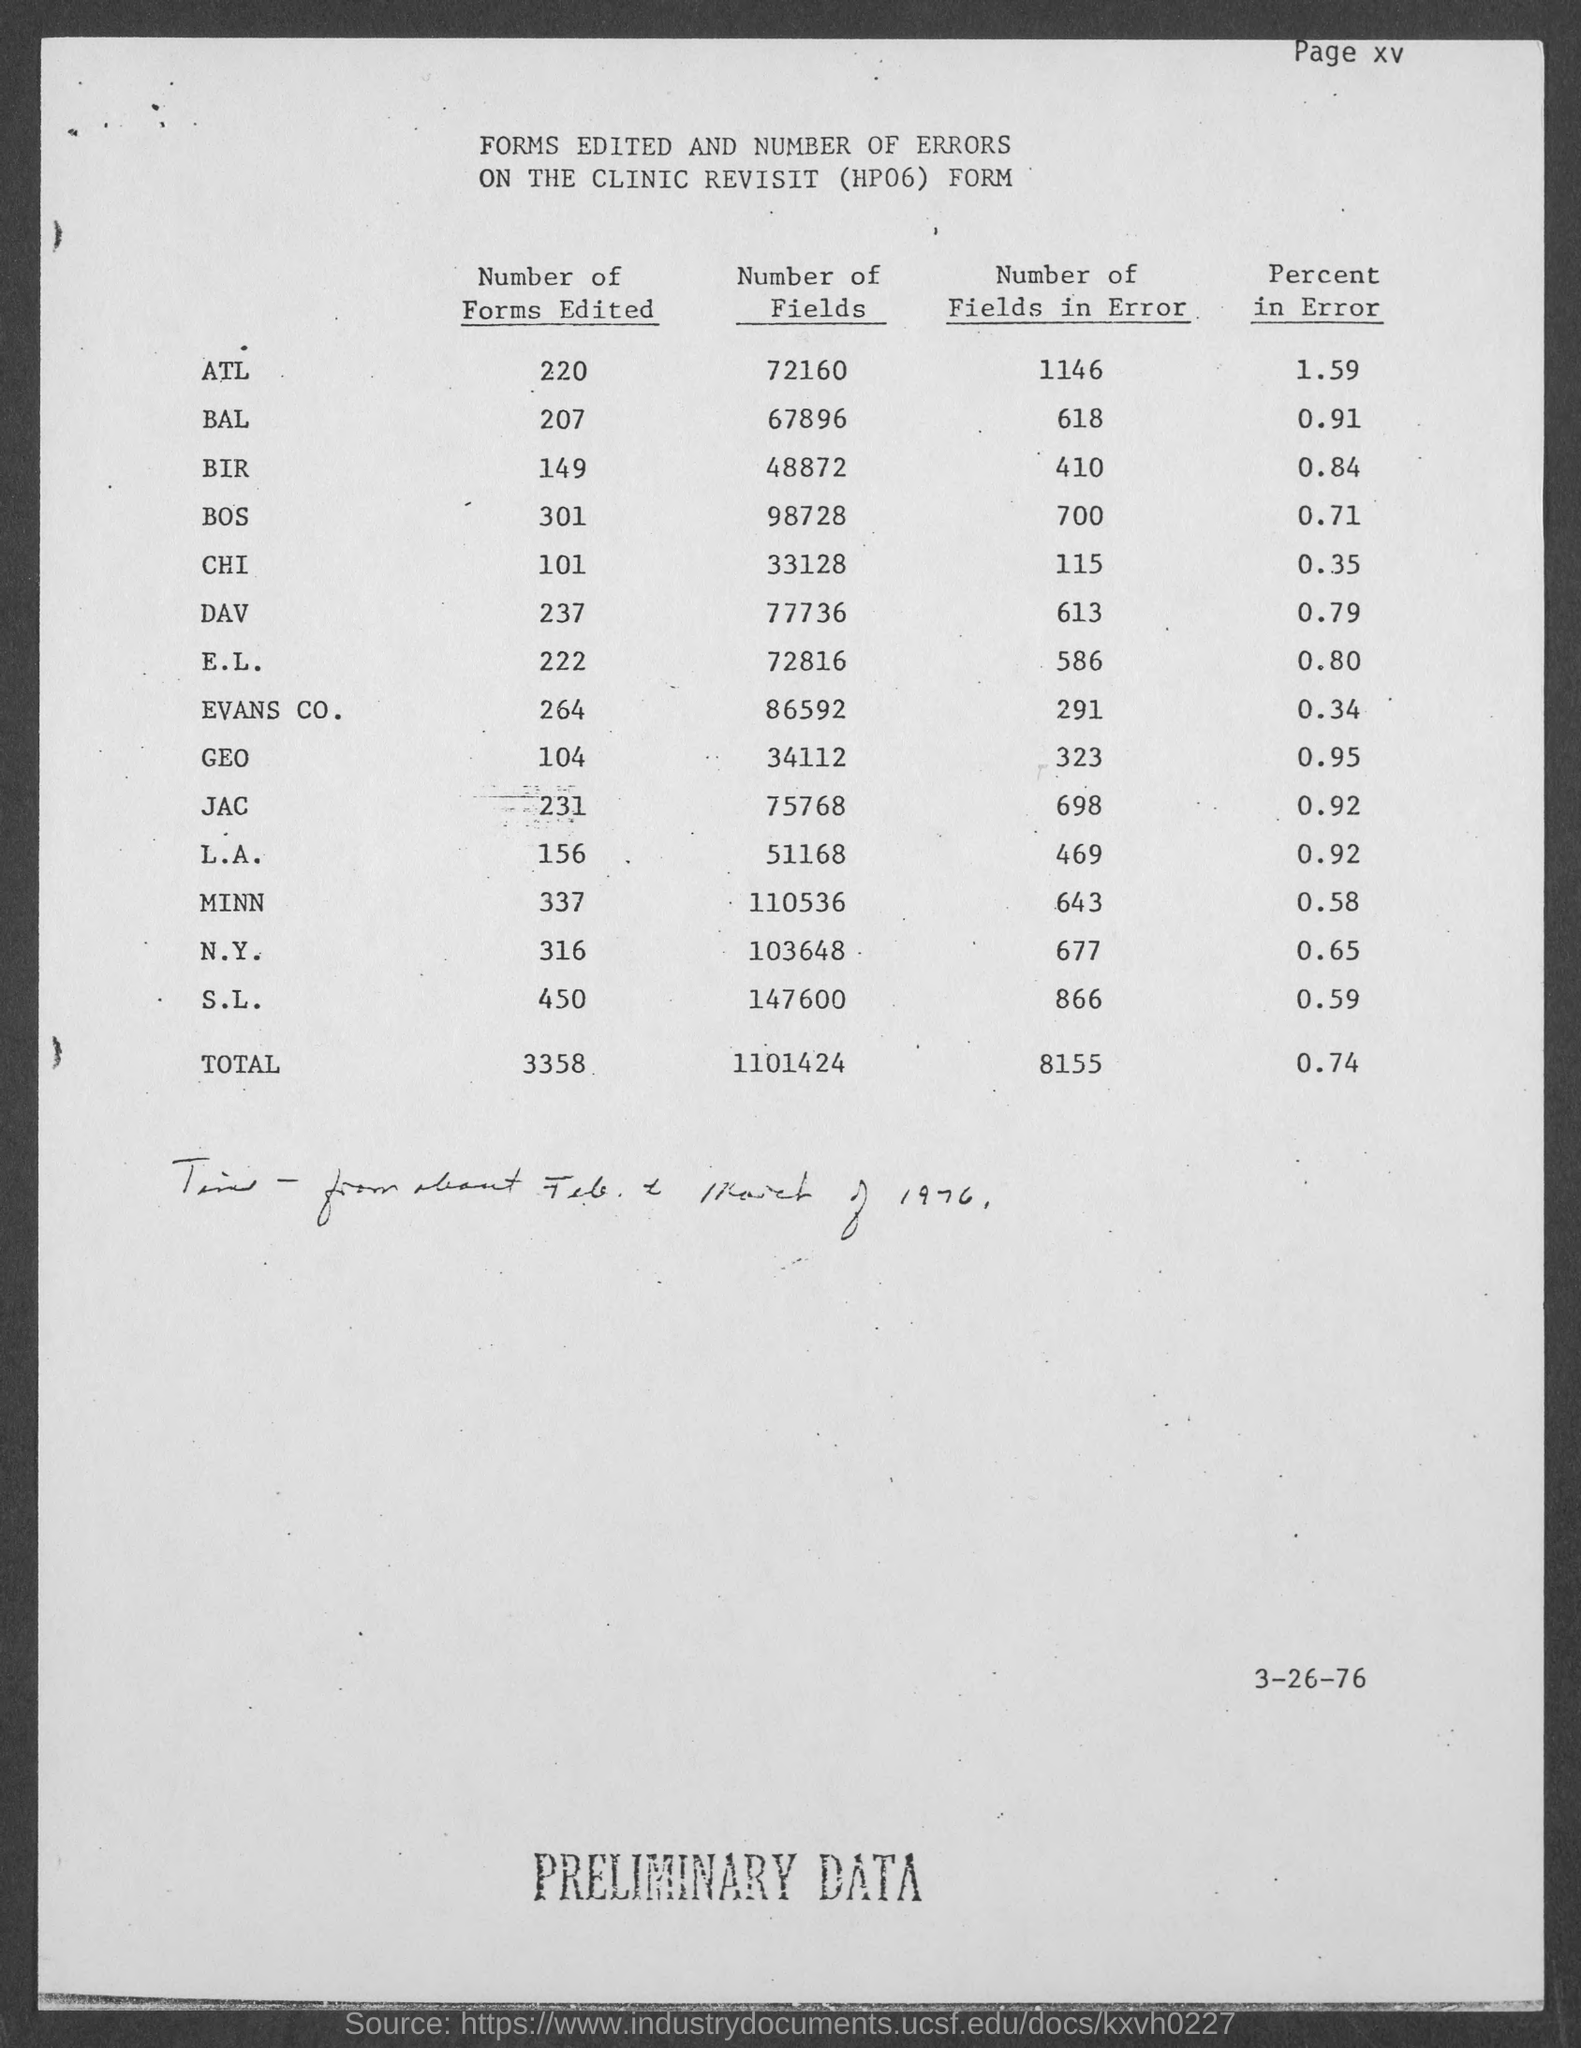Outline some significant characteristics in this image. A total of 207 BAL forms have been edited. The total number of fields is 1101424. The heading of the last column is "Percent in Error. Approximately 301 BOS forms have been edited. A total of 3358 forms have been edited. 